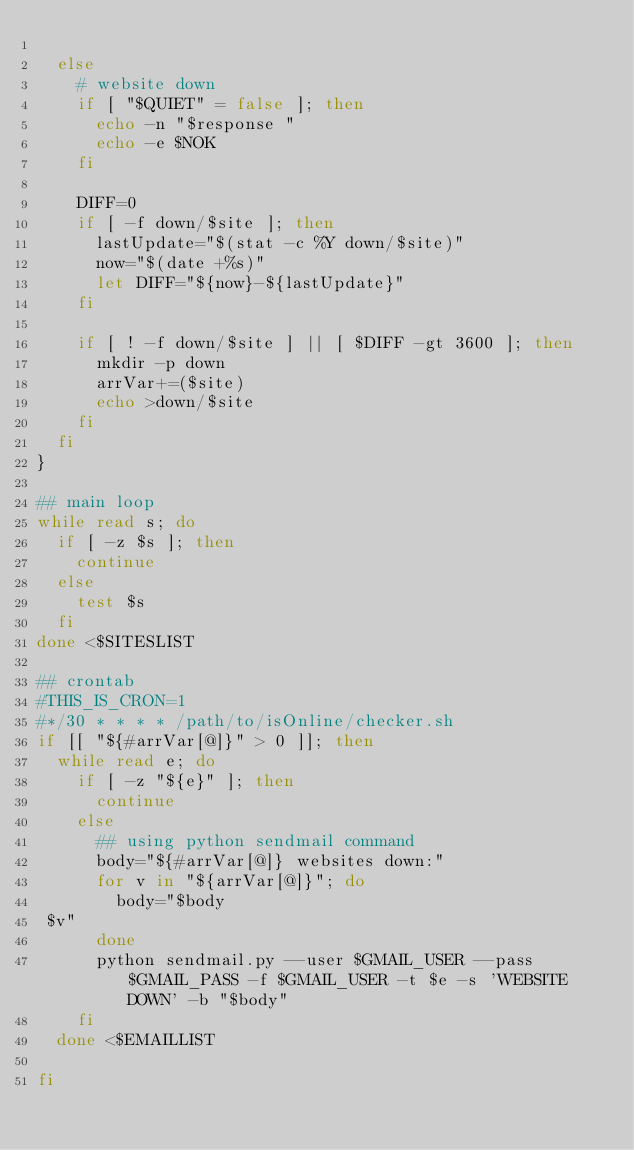Convert code to text. <code><loc_0><loc_0><loc_500><loc_500><_Bash_>
  else
    # website down
    if [ "$QUIET" = false ]; then
      echo -n "$response "
      echo -e $NOK
    fi

    DIFF=0
    if [ -f down/$site ]; then
      lastUpdate="$(stat -c %Y down/$site)"
      now="$(date +%s)"
      let DIFF="${now}-${lastUpdate}"
    fi

    if [ ! -f down/$site ] || [ $DIFF -gt 3600 ]; then
      mkdir -p down
      arrVar+=($site)
      echo >down/$site
    fi
  fi
}

## main loop
while read s; do
  if [ -z $s ]; then
    continue
  else
    test $s
  fi
done <$SITESLIST

## crontab
#THIS_IS_CRON=1
#*/30 * * * * /path/to/isOnline/checker.sh
if [[ "${#arrVar[@]}" > 0 ]]; then
  while read e; do
    if [ -z "${e}" ]; then
      continue
    else
      ## using python sendmail command
      body="${#arrVar[@]} websites down:"
      for v in "${arrVar[@]}"; do
        body="$body
 $v"
      done
      python sendmail.py --user $GMAIL_USER --pass $GMAIL_PASS -f $GMAIL_USER -t $e -s 'WEBSITE DOWN' -b "$body"
    fi
  done <$EMAILLIST

fi
</code> 